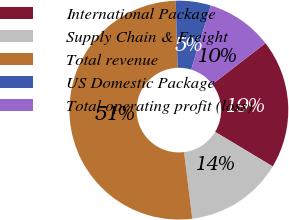Convert chart to OTSL. <chart><loc_0><loc_0><loc_500><loc_500><pie_chart><fcel>International Package<fcel>Supply Chain & Freight<fcel>Total revenue<fcel>US Domestic Package<fcel>Total operating profit (loss)<nl><fcel>19.07%<fcel>14.44%<fcel>51.49%<fcel>5.18%<fcel>9.81%<nl></chart> 